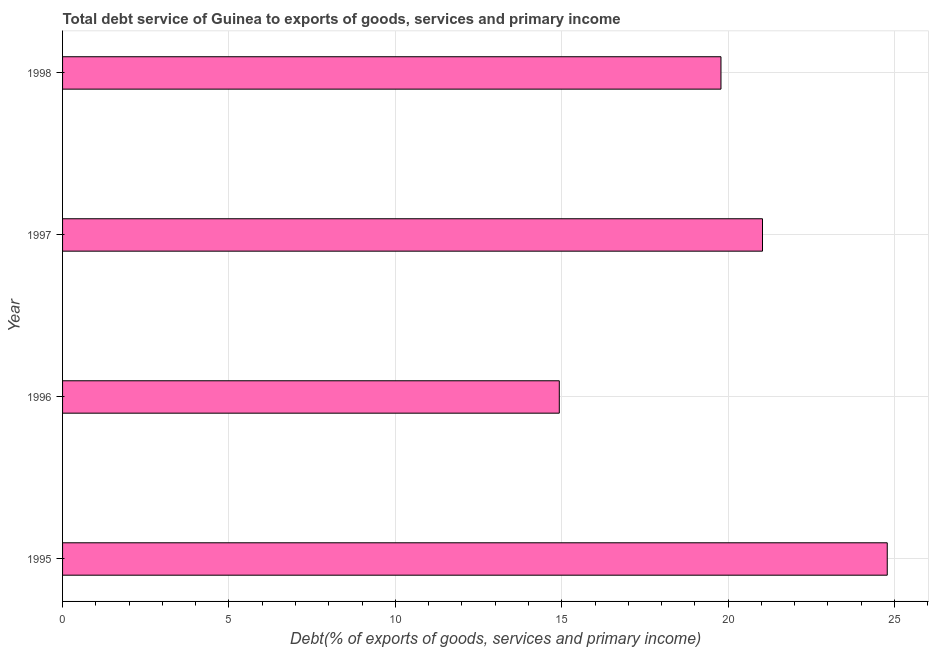What is the title of the graph?
Ensure brevity in your answer.  Total debt service of Guinea to exports of goods, services and primary income. What is the label or title of the X-axis?
Keep it short and to the point. Debt(% of exports of goods, services and primary income). What is the total debt service in 1998?
Offer a very short reply. 19.79. Across all years, what is the maximum total debt service?
Offer a very short reply. 24.78. Across all years, what is the minimum total debt service?
Ensure brevity in your answer.  14.93. In which year was the total debt service maximum?
Offer a terse response. 1995. In which year was the total debt service minimum?
Offer a terse response. 1996. What is the sum of the total debt service?
Give a very brief answer. 80.53. What is the difference between the total debt service in 1996 and 1997?
Keep it short and to the point. -6.11. What is the average total debt service per year?
Provide a succinct answer. 20.13. What is the median total debt service?
Ensure brevity in your answer.  20.41. In how many years, is the total debt service greater than 25 %?
Provide a succinct answer. 0. What is the ratio of the total debt service in 1996 to that in 1998?
Your answer should be compact. 0.75. Is the total debt service in 1996 less than that in 1998?
Your answer should be very brief. Yes. Is the difference between the total debt service in 1996 and 1998 greater than the difference between any two years?
Offer a terse response. No. What is the difference between the highest and the second highest total debt service?
Provide a succinct answer. 3.75. Is the sum of the total debt service in 1996 and 1997 greater than the maximum total debt service across all years?
Make the answer very short. Yes. What is the difference between the highest and the lowest total debt service?
Give a very brief answer. 9.86. In how many years, is the total debt service greater than the average total debt service taken over all years?
Give a very brief answer. 2. How many bars are there?
Your answer should be compact. 4. What is the difference between two consecutive major ticks on the X-axis?
Provide a short and direct response. 5. Are the values on the major ticks of X-axis written in scientific E-notation?
Your answer should be very brief. No. What is the Debt(% of exports of goods, services and primary income) of 1995?
Offer a terse response. 24.78. What is the Debt(% of exports of goods, services and primary income) in 1996?
Offer a very short reply. 14.93. What is the Debt(% of exports of goods, services and primary income) in 1997?
Provide a short and direct response. 21.03. What is the Debt(% of exports of goods, services and primary income) of 1998?
Offer a very short reply. 19.79. What is the difference between the Debt(% of exports of goods, services and primary income) in 1995 and 1996?
Offer a very short reply. 9.86. What is the difference between the Debt(% of exports of goods, services and primary income) in 1995 and 1997?
Give a very brief answer. 3.75. What is the difference between the Debt(% of exports of goods, services and primary income) in 1995 and 1998?
Give a very brief answer. 5. What is the difference between the Debt(% of exports of goods, services and primary income) in 1996 and 1997?
Offer a very short reply. -6.11. What is the difference between the Debt(% of exports of goods, services and primary income) in 1996 and 1998?
Provide a short and direct response. -4.86. What is the difference between the Debt(% of exports of goods, services and primary income) in 1997 and 1998?
Offer a very short reply. 1.25. What is the ratio of the Debt(% of exports of goods, services and primary income) in 1995 to that in 1996?
Your answer should be compact. 1.66. What is the ratio of the Debt(% of exports of goods, services and primary income) in 1995 to that in 1997?
Your answer should be compact. 1.18. What is the ratio of the Debt(% of exports of goods, services and primary income) in 1995 to that in 1998?
Provide a short and direct response. 1.25. What is the ratio of the Debt(% of exports of goods, services and primary income) in 1996 to that in 1997?
Ensure brevity in your answer.  0.71. What is the ratio of the Debt(% of exports of goods, services and primary income) in 1996 to that in 1998?
Your answer should be compact. 0.75. What is the ratio of the Debt(% of exports of goods, services and primary income) in 1997 to that in 1998?
Keep it short and to the point. 1.06. 